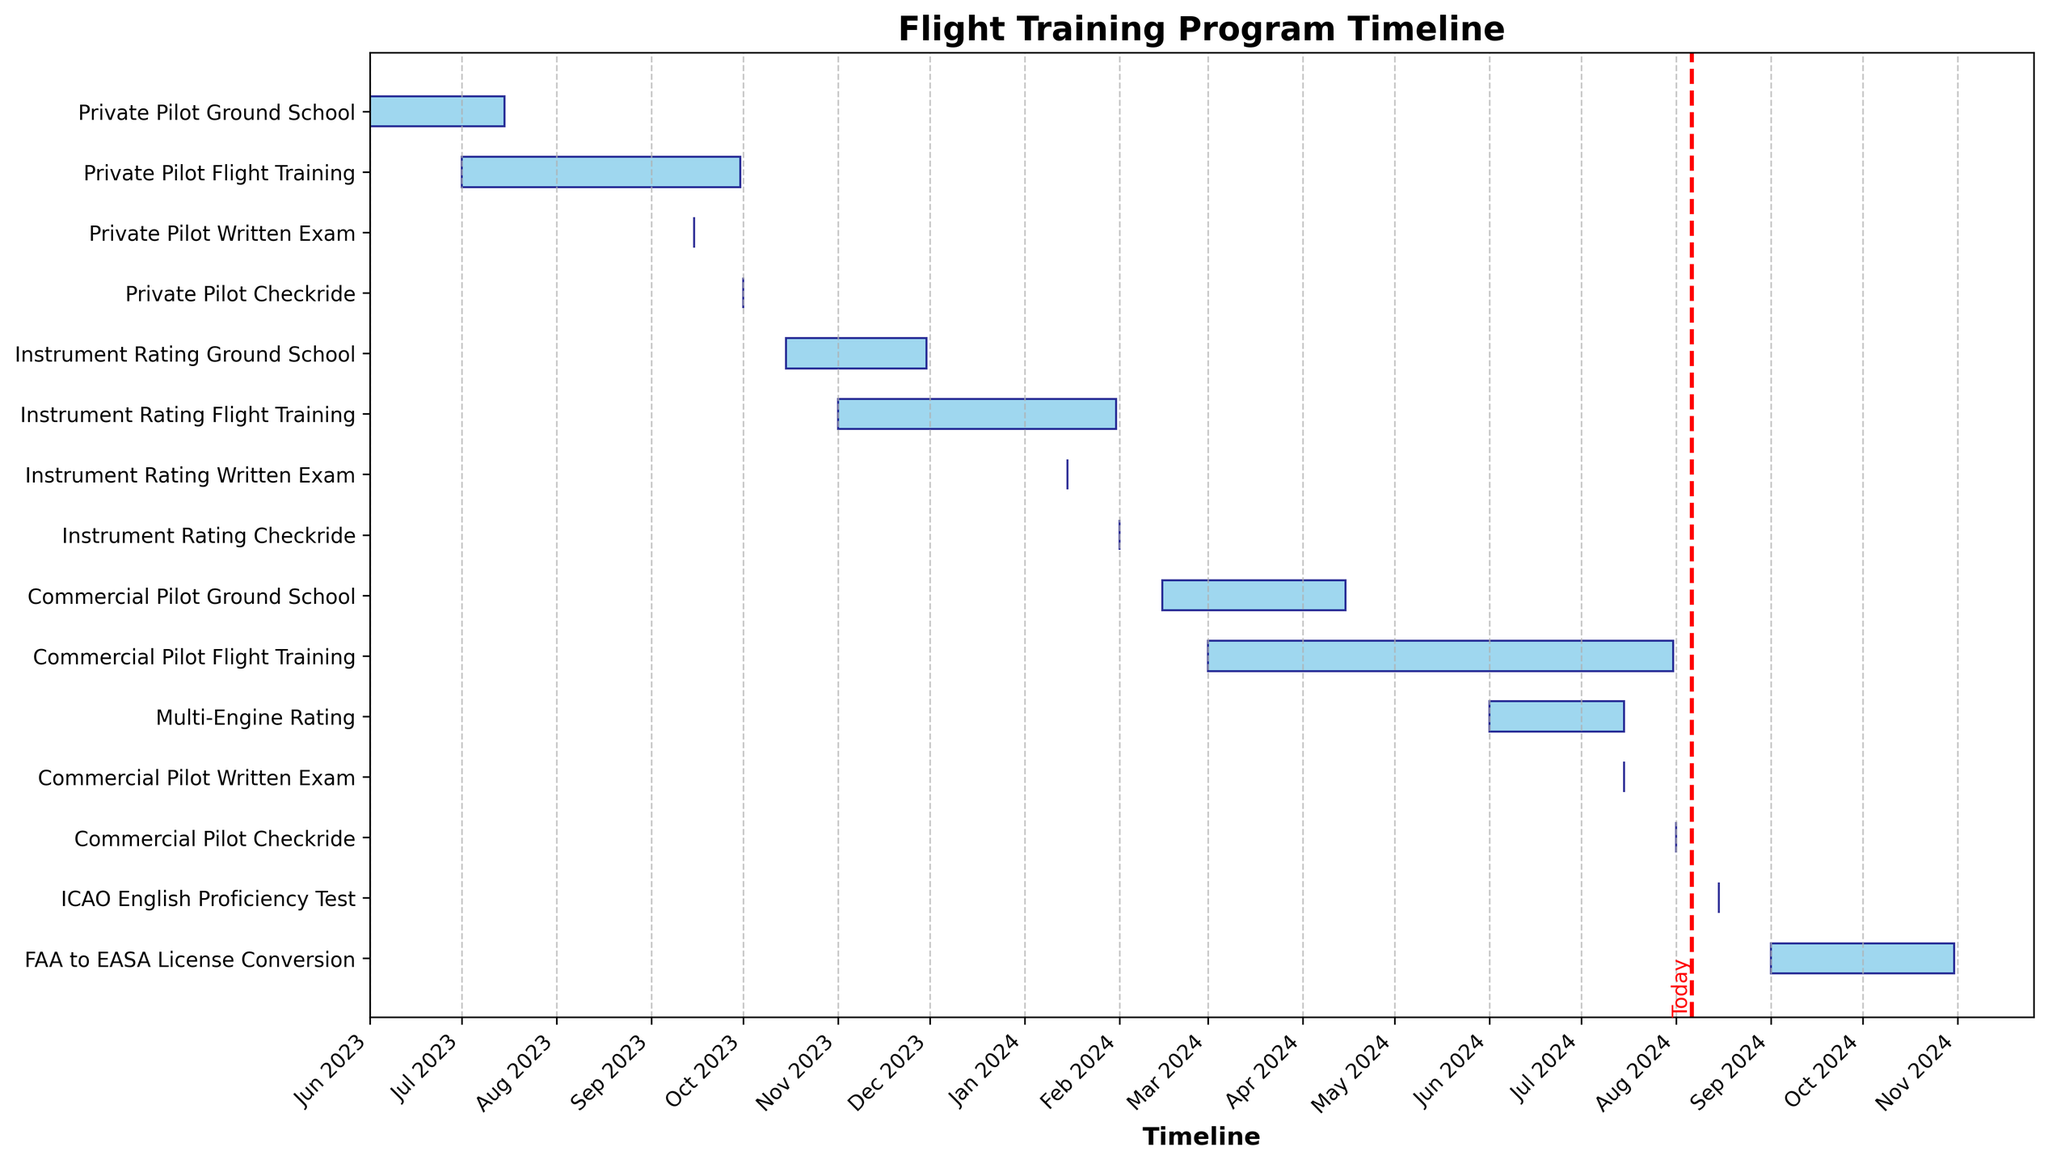What is the color of the bars representing the tasks? The bars representing the tasks in the Gantt Chart are colored sky blue with a navy edge. This can be observed directly from the visual appearance of the bars in the figure.
Answer: Sky blue with navy edge What is the title of the Gantt Chart? The title of the Gantt Chart is displayed at the top of the figure. It reads "Flight Training Program Timeline."
Answer: Flight Training Program Timeline Which task has the latest end date in the Gantt chart? By looking at the bars in the Gantt Chart, the task with the latest end date is the one that extends furthest on the x-axis. The "FAA to EASA License Conversion" task ends on 31st October 2024, which is the latest end date shown.
Answer: FAA to EASA License Conversion How long does the Private Pilot Flight Training take? To find the duration of the "Private Pilot Flight Training," calculate the difference between its start and end date. Private Pilot Flight Training starts on 1st July 2023 and ends on 30th September 2023. The duration in days can be found by subtracting the start date from the end date.
Answer: 92 days Which phase occupies the longest time period, and what is its duration? To determine the longest phase, we examine the length of the bars on the Gantt Chart. The "Commercial Pilot Flight Training" phase occupies the longest time period. This phase starts on 1st March 2024 and ends on 31st July 2024. The duration is calculated by subtracting the start date from the end date.
Answer: Commercial Pilot Flight Training, 153 days What is the shortest task mentioned in the Gantt Chart, and what is its duration? The shortest task in the Gantt Chart is the one with the shortest bar along the x-axis. Several tasks such as "Private Pilot Written Exam," "Private Pilot Checkride," "Instrument Rating Written Exam," "Instrument Rating Checkride," "Commercial Pilot Written Exam," "Commercial Pilot Checkride," and "ICAO English Proficiency Test" are all one-day tasks.
Answer: Private Pilot Written Exam, 1 day; Instrument Rating Written Exam, 1 day; Commercial Pilot Written Exam, 1 day; ICAO English Proficiency Test, 1 day Compare the start dates of the Private Pilot Ground School and the Commercial Pilot Ground School. Which one starts earlier? To compare the start dates, observe the leftmost extent of the respective bars for each task. The "Private Pilot Ground School" starts on 1st June 2023, whereas the "Commercial Pilot Ground School" starts on 15th February 2024. The Private Pilot Ground School starts earlier.
Answer: Private Pilot Ground School What tasks are planned to occur concurrently with the "Instrument Rating Flight Training"? To identify tasks occurring concurrently, look for overlapping bars on the y-axis with the "Instrument Rating Flight Training." The overlapping tasks are "Instrument Rating Written Exam" and "Commercial Pilot Ground School."
Answer: Instrument Rating Written Exam, Commercial Pilot Ground School How many months are covered in the flight training program from the start of the first task to the end of the last task? The first task starts on 1st June 2023, and the last task ends on 31st October 2024. Calculate the total period between these dates, which includes all the months covered. The total duration is approximately 17 months.
Answer: 17 months 